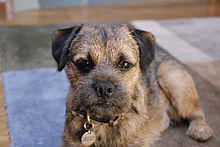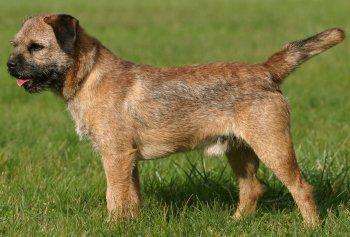The first image is the image on the left, the second image is the image on the right. For the images displayed, is the sentence "The dog on each image is facing the opposite direction of where the other is facing." factually correct? Answer yes or no. No. 